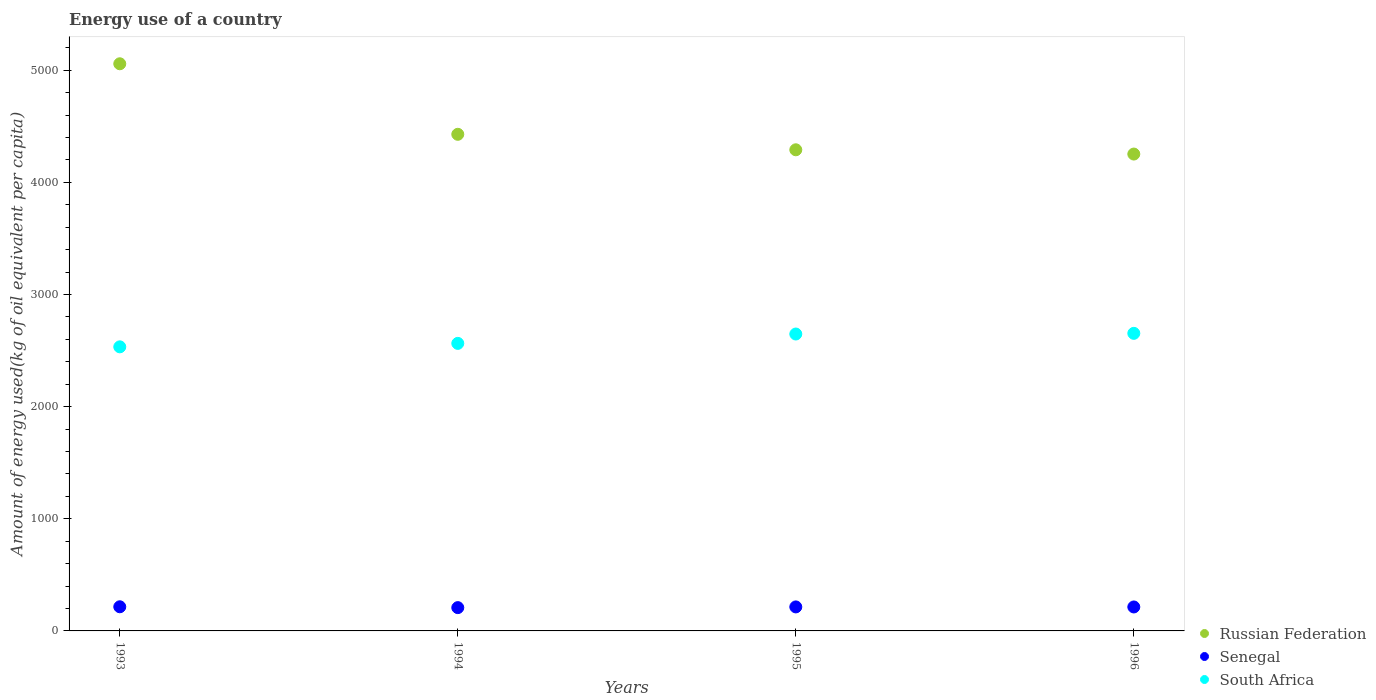Is the number of dotlines equal to the number of legend labels?
Provide a succinct answer. Yes. What is the amount of energy used in in South Africa in 1996?
Offer a terse response. 2653.81. Across all years, what is the maximum amount of energy used in in Russian Federation?
Your answer should be very brief. 5057.92. Across all years, what is the minimum amount of energy used in in Senegal?
Offer a terse response. 207.78. In which year was the amount of energy used in in Russian Federation minimum?
Make the answer very short. 1996. What is the total amount of energy used in in Senegal in the graph?
Provide a succinct answer. 850.83. What is the difference between the amount of energy used in in Senegal in 1993 and that in 1994?
Your answer should be compact. 7.54. What is the difference between the amount of energy used in in South Africa in 1994 and the amount of energy used in in Russian Federation in 1996?
Provide a short and direct response. -1688.46. What is the average amount of energy used in in Russian Federation per year?
Ensure brevity in your answer.  4507.58. In the year 1994, what is the difference between the amount of energy used in in Russian Federation and amount of energy used in in South Africa?
Make the answer very short. 1864.62. What is the ratio of the amount of energy used in in Russian Federation in 1993 to that in 1995?
Give a very brief answer. 1.18. What is the difference between the highest and the second highest amount of energy used in in Russian Federation?
Ensure brevity in your answer.  629.03. What is the difference between the highest and the lowest amount of energy used in in Senegal?
Your answer should be very brief. 7.54. Is the sum of the amount of energy used in in South Africa in 1993 and 1996 greater than the maximum amount of energy used in in Russian Federation across all years?
Your response must be concise. Yes. How many dotlines are there?
Provide a succinct answer. 3. Does the graph contain grids?
Ensure brevity in your answer.  No. Where does the legend appear in the graph?
Provide a succinct answer. Bottom right. What is the title of the graph?
Provide a succinct answer. Energy use of a country. What is the label or title of the X-axis?
Offer a terse response. Years. What is the label or title of the Y-axis?
Offer a very short reply. Amount of energy used(kg of oil equivalent per capita). What is the Amount of energy used(kg of oil equivalent per capita) of Russian Federation in 1993?
Offer a very short reply. 5057.92. What is the Amount of energy used(kg of oil equivalent per capita) in Senegal in 1993?
Keep it short and to the point. 215.32. What is the Amount of energy used(kg of oil equivalent per capita) of South Africa in 1993?
Offer a very short reply. 2533.45. What is the Amount of energy used(kg of oil equivalent per capita) of Russian Federation in 1994?
Provide a succinct answer. 4428.89. What is the Amount of energy used(kg of oil equivalent per capita) of Senegal in 1994?
Keep it short and to the point. 207.78. What is the Amount of energy used(kg of oil equivalent per capita) of South Africa in 1994?
Offer a very short reply. 2564.27. What is the Amount of energy used(kg of oil equivalent per capita) of Russian Federation in 1995?
Your answer should be compact. 4290.77. What is the Amount of energy used(kg of oil equivalent per capita) in Senegal in 1995?
Your answer should be compact. 214.08. What is the Amount of energy used(kg of oil equivalent per capita) in South Africa in 1995?
Give a very brief answer. 2647.77. What is the Amount of energy used(kg of oil equivalent per capita) in Russian Federation in 1996?
Provide a short and direct response. 4252.73. What is the Amount of energy used(kg of oil equivalent per capita) of Senegal in 1996?
Make the answer very short. 213.64. What is the Amount of energy used(kg of oil equivalent per capita) of South Africa in 1996?
Offer a very short reply. 2653.81. Across all years, what is the maximum Amount of energy used(kg of oil equivalent per capita) of Russian Federation?
Keep it short and to the point. 5057.92. Across all years, what is the maximum Amount of energy used(kg of oil equivalent per capita) of Senegal?
Offer a terse response. 215.32. Across all years, what is the maximum Amount of energy used(kg of oil equivalent per capita) of South Africa?
Provide a short and direct response. 2653.81. Across all years, what is the minimum Amount of energy used(kg of oil equivalent per capita) of Russian Federation?
Offer a terse response. 4252.73. Across all years, what is the minimum Amount of energy used(kg of oil equivalent per capita) in Senegal?
Keep it short and to the point. 207.78. Across all years, what is the minimum Amount of energy used(kg of oil equivalent per capita) in South Africa?
Your answer should be very brief. 2533.45. What is the total Amount of energy used(kg of oil equivalent per capita) of Russian Federation in the graph?
Ensure brevity in your answer.  1.80e+04. What is the total Amount of energy used(kg of oil equivalent per capita) of Senegal in the graph?
Your answer should be very brief. 850.83. What is the total Amount of energy used(kg of oil equivalent per capita) in South Africa in the graph?
Provide a succinct answer. 1.04e+04. What is the difference between the Amount of energy used(kg of oil equivalent per capita) of Russian Federation in 1993 and that in 1994?
Ensure brevity in your answer.  629.03. What is the difference between the Amount of energy used(kg of oil equivalent per capita) of Senegal in 1993 and that in 1994?
Keep it short and to the point. 7.54. What is the difference between the Amount of energy used(kg of oil equivalent per capita) in South Africa in 1993 and that in 1994?
Offer a terse response. -30.82. What is the difference between the Amount of energy used(kg of oil equivalent per capita) in Russian Federation in 1993 and that in 1995?
Give a very brief answer. 767.15. What is the difference between the Amount of energy used(kg of oil equivalent per capita) of Senegal in 1993 and that in 1995?
Your answer should be very brief. 1.23. What is the difference between the Amount of energy used(kg of oil equivalent per capita) in South Africa in 1993 and that in 1995?
Give a very brief answer. -114.32. What is the difference between the Amount of energy used(kg of oil equivalent per capita) in Russian Federation in 1993 and that in 1996?
Your answer should be compact. 805.19. What is the difference between the Amount of energy used(kg of oil equivalent per capita) in Senegal in 1993 and that in 1996?
Your answer should be compact. 1.67. What is the difference between the Amount of energy used(kg of oil equivalent per capita) of South Africa in 1993 and that in 1996?
Provide a short and direct response. -120.36. What is the difference between the Amount of energy used(kg of oil equivalent per capita) in Russian Federation in 1994 and that in 1995?
Offer a terse response. 138.12. What is the difference between the Amount of energy used(kg of oil equivalent per capita) in Senegal in 1994 and that in 1995?
Offer a terse response. -6.31. What is the difference between the Amount of energy used(kg of oil equivalent per capita) in South Africa in 1994 and that in 1995?
Give a very brief answer. -83.51. What is the difference between the Amount of energy used(kg of oil equivalent per capita) in Russian Federation in 1994 and that in 1996?
Make the answer very short. 176.16. What is the difference between the Amount of energy used(kg of oil equivalent per capita) in Senegal in 1994 and that in 1996?
Your answer should be very brief. -5.87. What is the difference between the Amount of energy used(kg of oil equivalent per capita) in South Africa in 1994 and that in 1996?
Make the answer very short. -89.54. What is the difference between the Amount of energy used(kg of oil equivalent per capita) in Russian Federation in 1995 and that in 1996?
Provide a short and direct response. 38.04. What is the difference between the Amount of energy used(kg of oil equivalent per capita) in Senegal in 1995 and that in 1996?
Provide a short and direct response. 0.44. What is the difference between the Amount of energy used(kg of oil equivalent per capita) in South Africa in 1995 and that in 1996?
Your response must be concise. -6.03. What is the difference between the Amount of energy used(kg of oil equivalent per capita) of Russian Federation in 1993 and the Amount of energy used(kg of oil equivalent per capita) of Senegal in 1994?
Provide a short and direct response. 4850.14. What is the difference between the Amount of energy used(kg of oil equivalent per capita) in Russian Federation in 1993 and the Amount of energy used(kg of oil equivalent per capita) in South Africa in 1994?
Your answer should be compact. 2493.65. What is the difference between the Amount of energy used(kg of oil equivalent per capita) of Senegal in 1993 and the Amount of energy used(kg of oil equivalent per capita) of South Africa in 1994?
Keep it short and to the point. -2348.95. What is the difference between the Amount of energy used(kg of oil equivalent per capita) in Russian Federation in 1993 and the Amount of energy used(kg of oil equivalent per capita) in Senegal in 1995?
Make the answer very short. 4843.84. What is the difference between the Amount of energy used(kg of oil equivalent per capita) of Russian Federation in 1993 and the Amount of energy used(kg of oil equivalent per capita) of South Africa in 1995?
Keep it short and to the point. 2410.15. What is the difference between the Amount of energy used(kg of oil equivalent per capita) of Senegal in 1993 and the Amount of energy used(kg of oil equivalent per capita) of South Africa in 1995?
Offer a very short reply. -2432.45. What is the difference between the Amount of energy used(kg of oil equivalent per capita) in Russian Federation in 1993 and the Amount of energy used(kg of oil equivalent per capita) in Senegal in 1996?
Provide a short and direct response. 4844.28. What is the difference between the Amount of energy used(kg of oil equivalent per capita) of Russian Federation in 1993 and the Amount of energy used(kg of oil equivalent per capita) of South Africa in 1996?
Offer a very short reply. 2404.11. What is the difference between the Amount of energy used(kg of oil equivalent per capita) of Senegal in 1993 and the Amount of energy used(kg of oil equivalent per capita) of South Africa in 1996?
Provide a succinct answer. -2438.49. What is the difference between the Amount of energy used(kg of oil equivalent per capita) in Russian Federation in 1994 and the Amount of energy used(kg of oil equivalent per capita) in Senegal in 1995?
Give a very brief answer. 4214.81. What is the difference between the Amount of energy used(kg of oil equivalent per capita) of Russian Federation in 1994 and the Amount of energy used(kg of oil equivalent per capita) of South Africa in 1995?
Ensure brevity in your answer.  1781.12. What is the difference between the Amount of energy used(kg of oil equivalent per capita) in Senegal in 1994 and the Amount of energy used(kg of oil equivalent per capita) in South Africa in 1995?
Make the answer very short. -2440. What is the difference between the Amount of energy used(kg of oil equivalent per capita) in Russian Federation in 1994 and the Amount of energy used(kg of oil equivalent per capita) in Senegal in 1996?
Keep it short and to the point. 4215.24. What is the difference between the Amount of energy used(kg of oil equivalent per capita) of Russian Federation in 1994 and the Amount of energy used(kg of oil equivalent per capita) of South Africa in 1996?
Keep it short and to the point. 1775.08. What is the difference between the Amount of energy used(kg of oil equivalent per capita) of Senegal in 1994 and the Amount of energy used(kg of oil equivalent per capita) of South Africa in 1996?
Your response must be concise. -2446.03. What is the difference between the Amount of energy used(kg of oil equivalent per capita) in Russian Federation in 1995 and the Amount of energy used(kg of oil equivalent per capita) in Senegal in 1996?
Your response must be concise. 4077.13. What is the difference between the Amount of energy used(kg of oil equivalent per capita) of Russian Federation in 1995 and the Amount of energy used(kg of oil equivalent per capita) of South Africa in 1996?
Give a very brief answer. 1636.97. What is the difference between the Amount of energy used(kg of oil equivalent per capita) of Senegal in 1995 and the Amount of energy used(kg of oil equivalent per capita) of South Africa in 1996?
Provide a succinct answer. -2439.72. What is the average Amount of energy used(kg of oil equivalent per capita) of Russian Federation per year?
Keep it short and to the point. 4507.58. What is the average Amount of energy used(kg of oil equivalent per capita) in Senegal per year?
Make the answer very short. 212.71. What is the average Amount of energy used(kg of oil equivalent per capita) in South Africa per year?
Give a very brief answer. 2599.82. In the year 1993, what is the difference between the Amount of energy used(kg of oil equivalent per capita) in Russian Federation and Amount of energy used(kg of oil equivalent per capita) in Senegal?
Your answer should be very brief. 4842.6. In the year 1993, what is the difference between the Amount of energy used(kg of oil equivalent per capita) in Russian Federation and Amount of energy used(kg of oil equivalent per capita) in South Africa?
Keep it short and to the point. 2524.47. In the year 1993, what is the difference between the Amount of energy used(kg of oil equivalent per capita) of Senegal and Amount of energy used(kg of oil equivalent per capita) of South Africa?
Your response must be concise. -2318.13. In the year 1994, what is the difference between the Amount of energy used(kg of oil equivalent per capita) of Russian Federation and Amount of energy used(kg of oil equivalent per capita) of Senegal?
Provide a succinct answer. 4221.11. In the year 1994, what is the difference between the Amount of energy used(kg of oil equivalent per capita) of Russian Federation and Amount of energy used(kg of oil equivalent per capita) of South Africa?
Keep it short and to the point. 1864.62. In the year 1994, what is the difference between the Amount of energy used(kg of oil equivalent per capita) of Senegal and Amount of energy used(kg of oil equivalent per capita) of South Africa?
Make the answer very short. -2356.49. In the year 1995, what is the difference between the Amount of energy used(kg of oil equivalent per capita) in Russian Federation and Amount of energy used(kg of oil equivalent per capita) in Senegal?
Offer a terse response. 4076.69. In the year 1995, what is the difference between the Amount of energy used(kg of oil equivalent per capita) in Russian Federation and Amount of energy used(kg of oil equivalent per capita) in South Africa?
Your answer should be very brief. 1643. In the year 1995, what is the difference between the Amount of energy used(kg of oil equivalent per capita) in Senegal and Amount of energy used(kg of oil equivalent per capita) in South Africa?
Ensure brevity in your answer.  -2433.69. In the year 1996, what is the difference between the Amount of energy used(kg of oil equivalent per capita) in Russian Federation and Amount of energy used(kg of oil equivalent per capita) in Senegal?
Provide a succinct answer. 4039.08. In the year 1996, what is the difference between the Amount of energy used(kg of oil equivalent per capita) of Russian Federation and Amount of energy used(kg of oil equivalent per capita) of South Africa?
Your response must be concise. 1598.92. In the year 1996, what is the difference between the Amount of energy used(kg of oil equivalent per capita) in Senegal and Amount of energy used(kg of oil equivalent per capita) in South Africa?
Give a very brief answer. -2440.16. What is the ratio of the Amount of energy used(kg of oil equivalent per capita) of Russian Federation in 1993 to that in 1994?
Make the answer very short. 1.14. What is the ratio of the Amount of energy used(kg of oil equivalent per capita) of Senegal in 1993 to that in 1994?
Provide a succinct answer. 1.04. What is the ratio of the Amount of energy used(kg of oil equivalent per capita) of South Africa in 1993 to that in 1994?
Ensure brevity in your answer.  0.99. What is the ratio of the Amount of energy used(kg of oil equivalent per capita) in Russian Federation in 1993 to that in 1995?
Give a very brief answer. 1.18. What is the ratio of the Amount of energy used(kg of oil equivalent per capita) in South Africa in 1993 to that in 1995?
Provide a short and direct response. 0.96. What is the ratio of the Amount of energy used(kg of oil equivalent per capita) of Russian Federation in 1993 to that in 1996?
Your response must be concise. 1.19. What is the ratio of the Amount of energy used(kg of oil equivalent per capita) in South Africa in 1993 to that in 1996?
Give a very brief answer. 0.95. What is the ratio of the Amount of energy used(kg of oil equivalent per capita) in Russian Federation in 1994 to that in 1995?
Make the answer very short. 1.03. What is the ratio of the Amount of energy used(kg of oil equivalent per capita) in Senegal in 1994 to that in 1995?
Your answer should be compact. 0.97. What is the ratio of the Amount of energy used(kg of oil equivalent per capita) in South Africa in 1994 to that in 1995?
Give a very brief answer. 0.97. What is the ratio of the Amount of energy used(kg of oil equivalent per capita) in Russian Federation in 1994 to that in 1996?
Provide a succinct answer. 1.04. What is the ratio of the Amount of energy used(kg of oil equivalent per capita) in Senegal in 1994 to that in 1996?
Your response must be concise. 0.97. What is the ratio of the Amount of energy used(kg of oil equivalent per capita) in South Africa in 1994 to that in 1996?
Give a very brief answer. 0.97. What is the ratio of the Amount of energy used(kg of oil equivalent per capita) of Russian Federation in 1995 to that in 1996?
Provide a succinct answer. 1.01. What is the ratio of the Amount of energy used(kg of oil equivalent per capita) of South Africa in 1995 to that in 1996?
Give a very brief answer. 1. What is the difference between the highest and the second highest Amount of energy used(kg of oil equivalent per capita) of Russian Federation?
Give a very brief answer. 629.03. What is the difference between the highest and the second highest Amount of energy used(kg of oil equivalent per capita) in Senegal?
Provide a short and direct response. 1.23. What is the difference between the highest and the second highest Amount of energy used(kg of oil equivalent per capita) in South Africa?
Your answer should be very brief. 6.03. What is the difference between the highest and the lowest Amount of energy used(kg of oil equivalent per capita) in Russian Federation?
Offer a very short reply. 805.19. What is the difference between the highest and the lowest Amount of energy used(kg of oil equivalent per capita) in Senegal?
Make the answer very short. 7.54. What is the difference between the highest and the lowest Amount of energy used(kg of oil equivalent per capita) in South Africa?
Give a very brief answer. 120.36. 